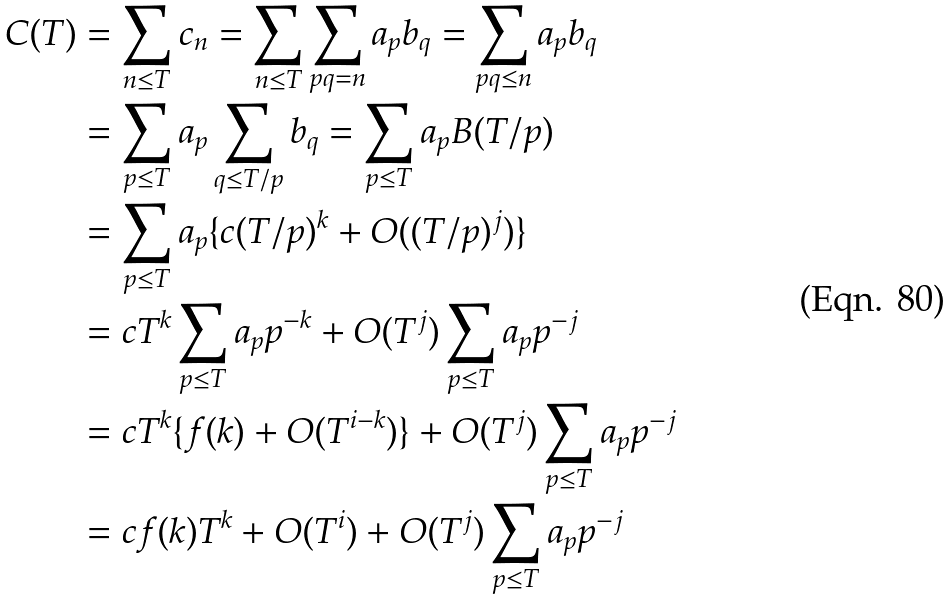Convert formula to latex. <formula><loc_0><loc_0><loc_500><loc_500>C ( T ) & = \sum _ { n \leq T } c _ { n } = \sum _ { n \leq T } \sum _ { p q = n } a _ { p } b _ { q } = \sum _ { p q \leq n } a _ { p } b _ { q } \\ & = \sum _ { p \leq T } a _ { p } \sum _ { q \leq T / p } b _ { q } = \sum _ { p \leq T } a _ { p } B ( T / p ) \\ & = \sum _ { p \leq T } a _ { p } \{ c ( T / p ) ^ { k } + O ( ( T / p ) ^ { j } ) \} \\ & = c T ^ { k } \sum _ { p \leq T } a _ { p } p ^ { - k } + O ( T ^ { j } ) \sum _ { p \leq T } a _ { p } p ^ { - j } \\ & = c T ^ { k } \{ f ( k ) + O ( T ^ { i - k } ) \} + O ( T ^ { j } ) \sum _ { p \leq T } a _ { p } p ^ { - j } \\ & = c f ( k ) T ^ { k } + O ( T ^ { i } ) + O ( T ^ { j } ) \sum _ { p \leq T } a _ { p } p ^ { - j }</formula> 